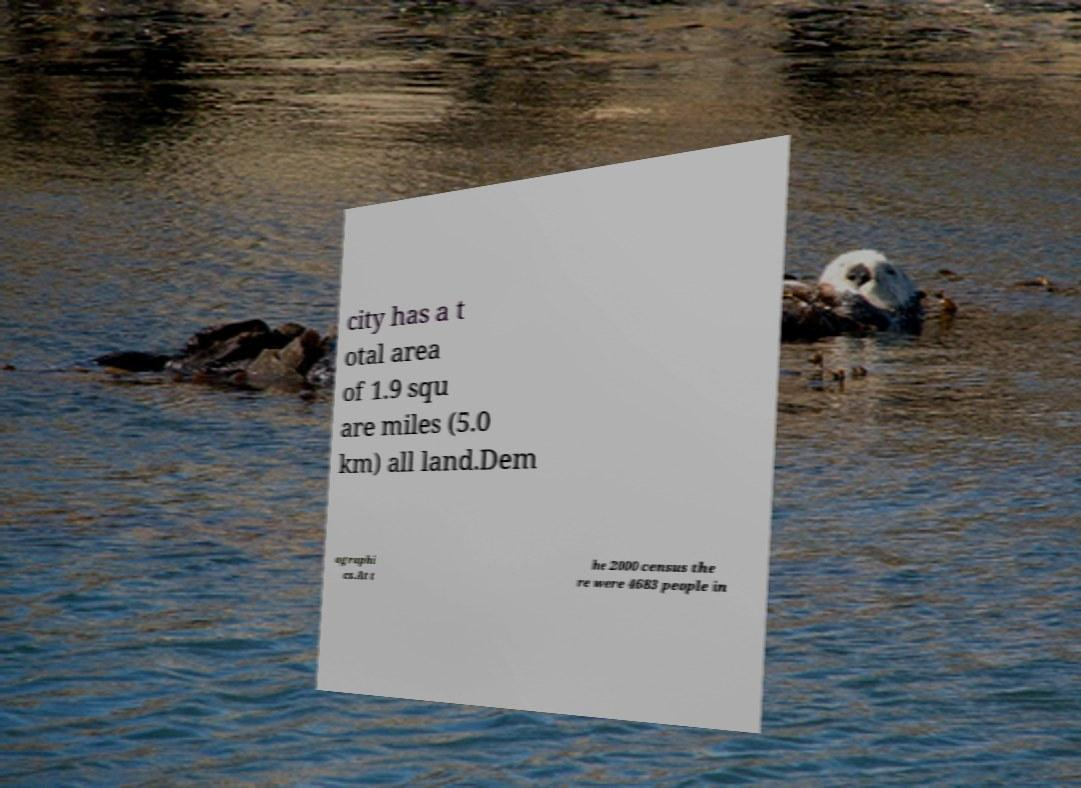Could you assist in decoding the text presented in this image and type it out clearly? city has a t otal area of 1.9 squ are miles (5.0 km) all land.Dem ographi cs.At t he 2000 census the re were 4683 people in 